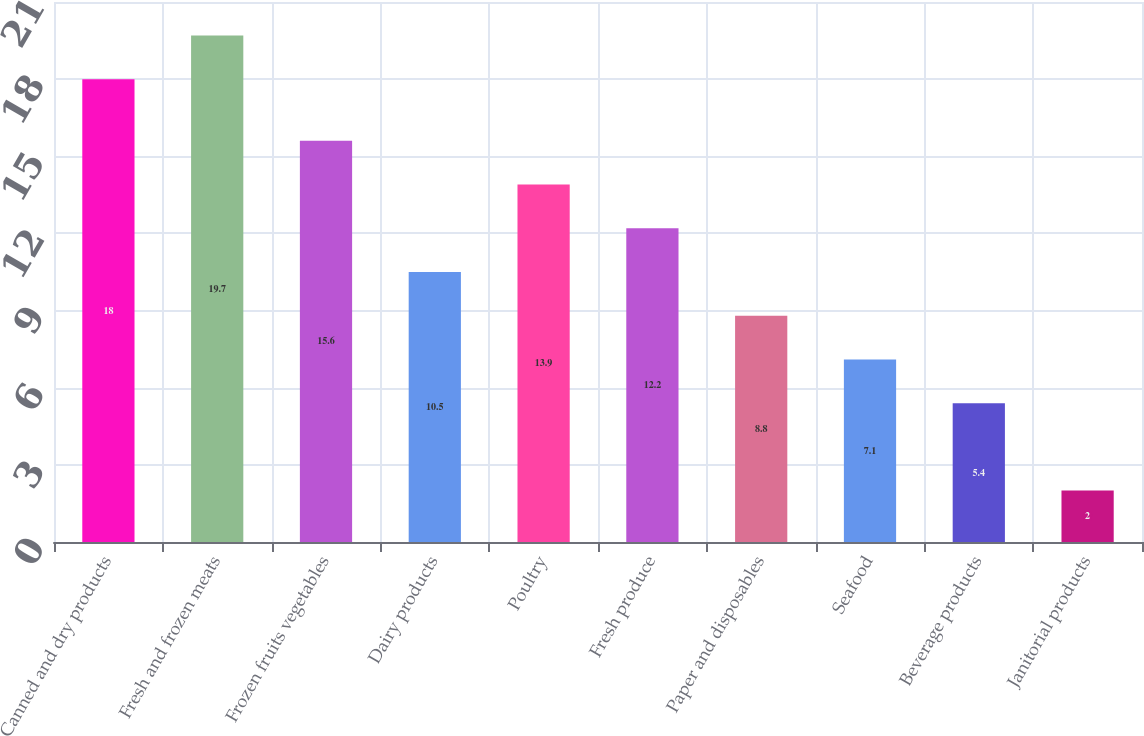Convert chart. <chart><loc_0><loc_0><loc_500><loc_500><bar_chart><fcel>Canned and dry products<fcel>Fresh and frozen meats<fcel>Frozen fruits vegetables<fcel>Dairy products<fcel>Poultry<fcel>Fresh produce<fcel>Paper and disposables<fcel>Seafood<fcel>Beverage products<fcel>Janitorial products<nl><fcel>18<fcel>19.7<fcel>15.6<fcel>10.5<fcel>13.9<fcel>12.2<fcel>8.8<fcel>7.1<fcel>5.4<fcel>2<nl></chart> 